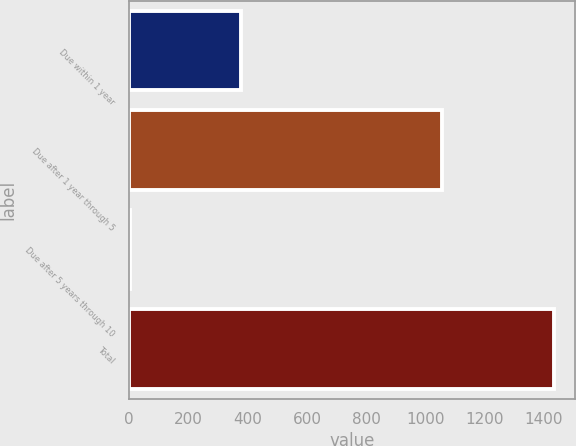Convert chart to OTSL. <chart><loc_0><loc_0><loc_500><loc_500><bar_chart><fcel>Due within 1 year<fcel>Due after 1 year through 5<fcel>Due after 5 years through 10<fcel>Total<nl><fcel>376<fcel>1056<fcel>1<fcel>1433<nl></chart> 